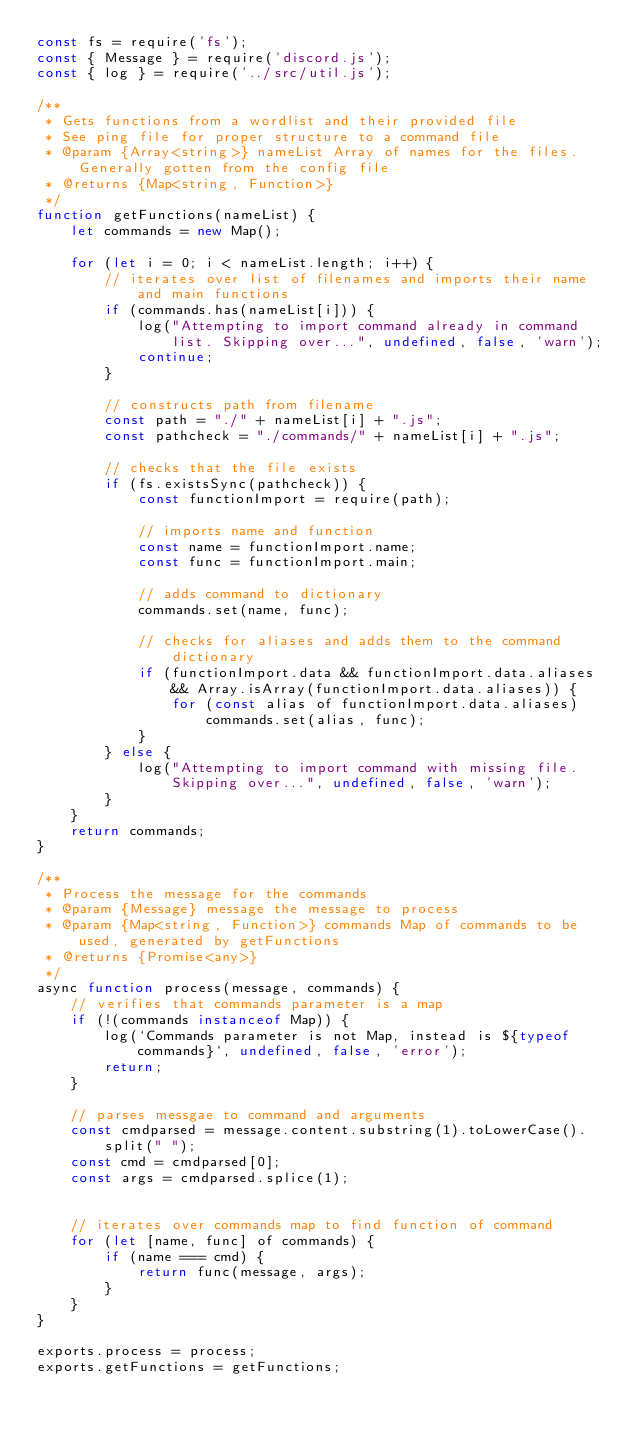Convert code to text. <code><loc_0><loc_0><loc_500><loc_500><_JavaScript_>const fs = require('fs');
const { Message } = require('discord.js');
const { log } = require('../src/util.js');

/**
 * Gets functions from a wordlist and their provided file
 * See ping file for proper structure to a command file
 * @param {Array<string>} nameList Array of names for the files. Generally gotten from the config file
 * @returns {Map<string, Function>}
 */
function getFunctions(nameList) {
    let commands = new Map();

    for (let i = 0; i < nameList.length; i++) {
        // iterates over list of filenames and imports their name and main functions
        if (commands.has(nameList[i])) {
            log("Attempting to import command already in command list. Skipping over...", undefined, false, 'warn');
            continue;
        }

        // constructs path from filename
        const path = "./" + nameList[i] + ".js";
        const pathcheck = "./commands/" + nameList[i] + ".js";

        // checks that the file exists
        if (fs.existsSync(pathcheck)) {
            const functionImport = require(path);

            // imports name and function
            const name = functionImport.name;
            const func = functionImport.main;

            // adds command to dictionary
            commands.set(name, func);

            // checks for aliases and adds them to the command dictionary
            if (functionImport.data && functionImport.data.aliases && Array.isArray(functionImport.data.aliases)) {
                for (const alias of functionImport.data.aliases)
                    commands.set(alias, func);
            }
        } else {
            log("Attempting to import command with missing file. Skipping over...", undefined, false, 'warn');
        }
    }
    return commands;
}

/**
 * Process the message for the commands
 * @param {Message} message the message to process
 * @param {Map<string, Function>} commands Map of commands to be used, generated by getFunctions
 * @returns {Promise<any>}
 */
async function process(message, commands) {
    // verifies that commands parameter is a map
    if (!(commands instanceof Map)) {
        log(`Commands parameter is not Map, instead is ${typeof commands}`, undefined, false, 'error');
        return;
    }

    // parses messgae to command and arguments
    const cmdparsed = message.content.substring(1).toLowerCase().split(" ");
    const cmd = cmdparsed[0];
    const args = cmdparsed.splice(1);


    // iterates over commands map to find function of command
    for (let [name, func] of commands) {
        if (name === cmd) {
            return func(message, args);
        }
    }
}

exports.process = process;
exports.getFunctions = getFunctions;</code> 